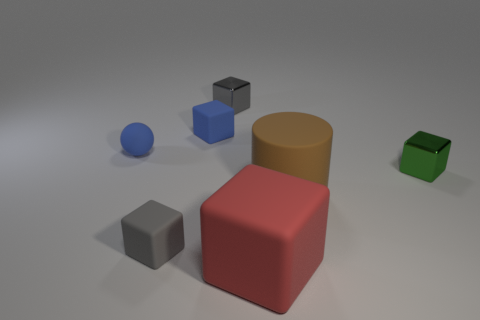How big is the thing that is both in front of the green thing and to the right of the big block?
Offer a terse response. Large. There is a tiny block that is both on the left side of the small gray metallic object and behind the tiny gray rubber cube; what color is it?
Make the answer very short. Blue. Is the number of red matte things that are behind the ball less than the number of red blocks that are in front of the brown rubber cylinder?
Your answer should be compact. Yes. Is there anything else of the same color as the matte ball?
Provide a short and direct response. Yes. There is a brown object; what shape is it?
Provide a succinct answer. Cylinder. The large cylinder that is the same material as the small sphere is what color?
Provide a succinct answer. Brown. Are there more big brown rubber cubes than small gray objects?
Your answer should be compact. No. Are any tiny gray matte balls visible?
Make the answer very short. No. There is a gray thing behind the small rubber cube that is in front of the green metallic object; what is its shape?
Give a very brief answer. Cube. What number of things are small blue spheres or tiny metallic cubes that are left of the matte cylinder?
Ensure brevity in your answer.  2. 